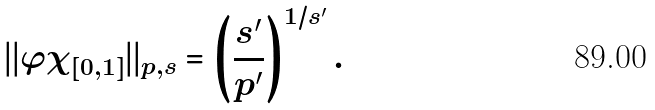Convert formula to latex. <formula><loc_0><loc_0><loc_500><loc_500>| | \varphi \chi _ { [ 0 , 1 ] } | | _ { p , s } = \left ( \frac { s ^ { \prime } } { p ^ { \prime } } \right ) ^ { 1 / s ^ { \prime } } .</formula> 